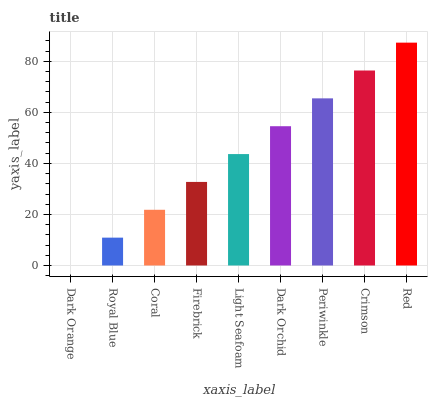Is Dark Orange the minimum?
Answer yes or no. Yes. Is Red the maximum?
Answer yes or no. Yes. Is Royal Blue the minimum?
Answer yes or no. No. Is Royal Blue the maximum?
Answer yes or no. No. Is Royal Blue greater than Dark Orange?
Answer yes or no. Yes. Is Dark Orange less than Royal Blue?
Answer yes or no. Yes. Is Dark Orange greater than Royal Blue?
Answer yes or no. No. Is Royal Blue less than Dark Orange?
Answer yes or no. No. Is Light Seafoam the high median?
Answer yes or no. Yes. Is Light Seafoam the low median?
Answer yes or no. Yes. Is Dark Orange the high median?
Answer yes or no. No. Is Royal Blue the low median?
Answer yes or no. No. 